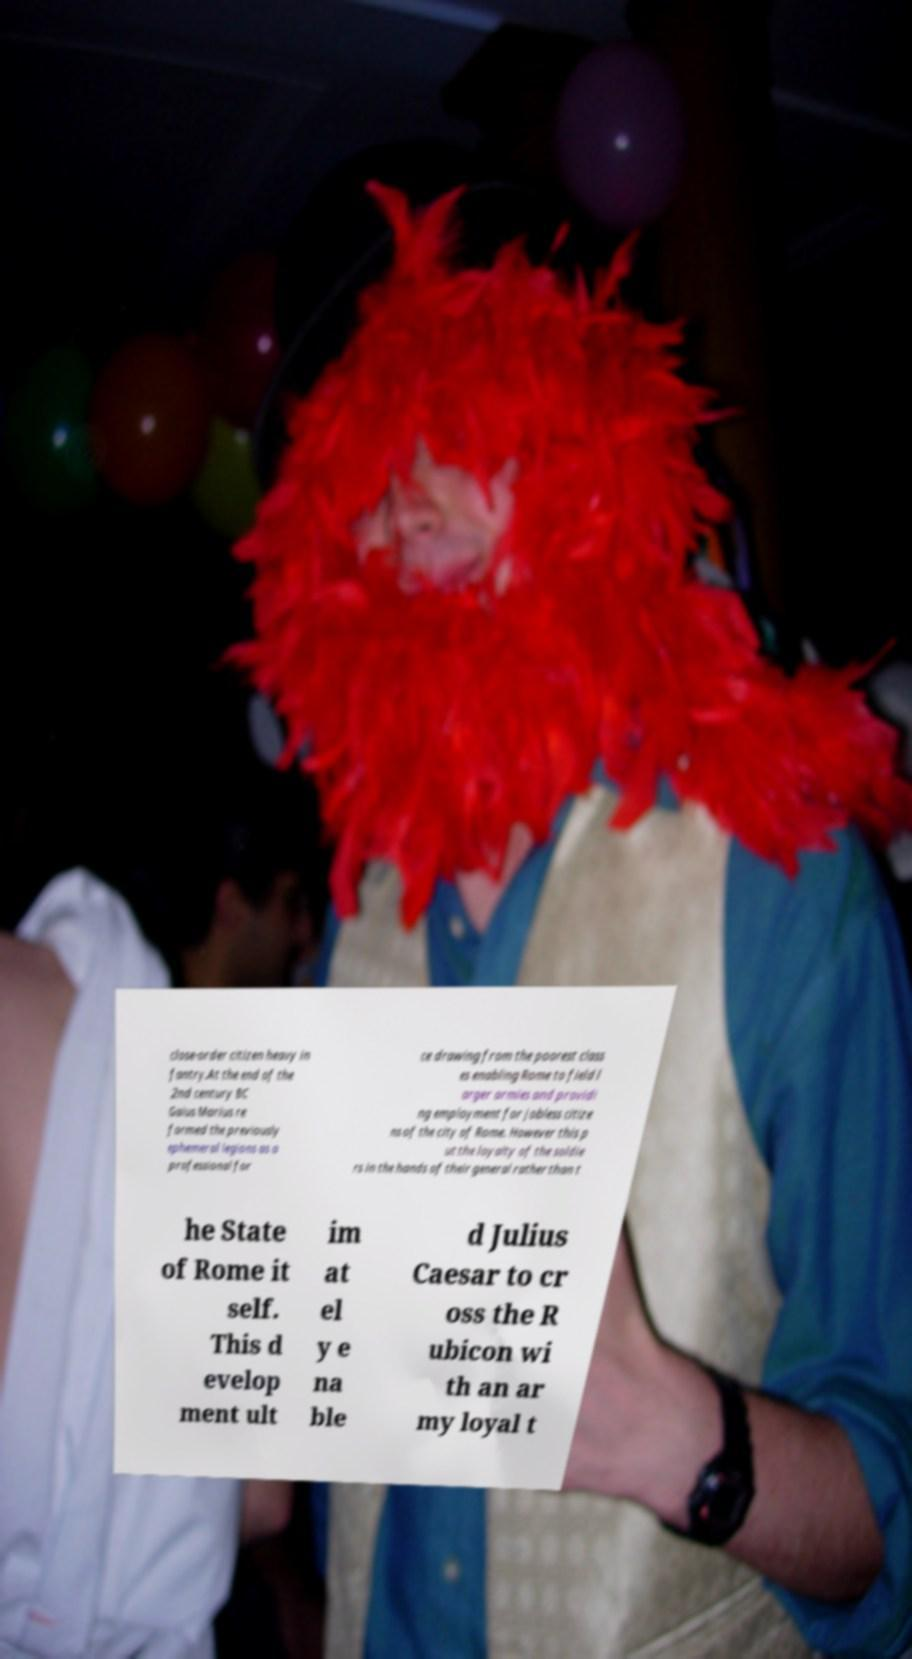For documentation purposes, I need the text within this image transcribed. Could you provide that? close-order citizen heavy in fantry.At the end of the 2nd century BC Gaius Marius re formed the previously ephemeral legions as a professional for ce drawing from the poorest class es enabling Rome to field l arger armies and providi ng employment for jobless citize ns of the city of Rome. However this p ut the loyalty of the soldie rs in the hands of their general rather than t he State of Rome it self. This d evelop ment ult im at el y e na ble d Julius Caesar to cr oss the R ubicon wi th an ar my loyal t 